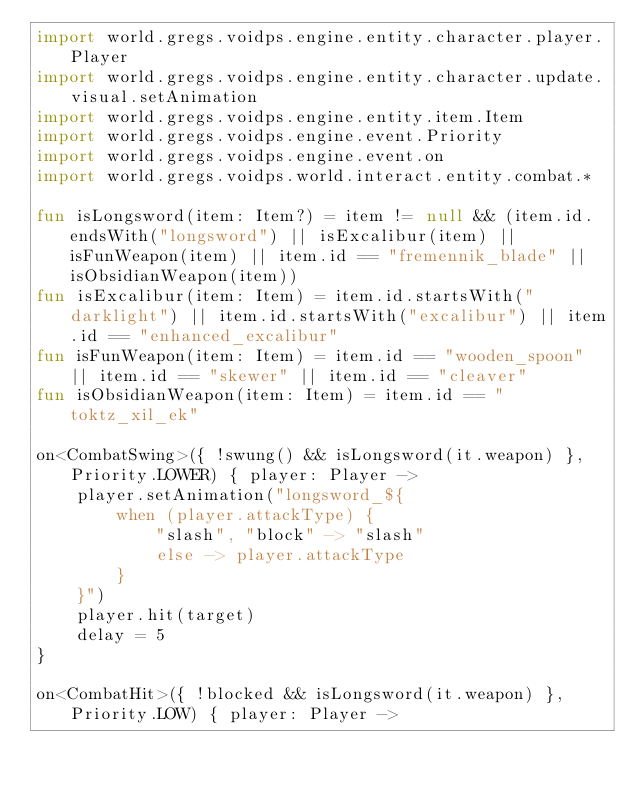Convert code to text. <code><loc_0><loc_0><loc_500><loc_500><_Kotlin_>import world.gregs.voidps.engine.entity.character.player.Player
import world.gregs.voidps.engine.entity.character.update.visual.setAnimation
import world.gregs.voidps.engine.entity.item.Item
import world.gregs.voidps.engine.event.Priority
import world.gregs.voidps.engine.event.on
import world.gregs.voidps.world.interact.entity.combat.*

fun isLongsword(item: Item?) = item != null && (item.id.endsWith("longsword") || isExcalibur(item) || isFunWeapon(item) || item.id == "fremennik_blade" || isObsidianWeapon(item))
fun isExcalibur(item: Item) = item.id.startsWith("darklight") || item.id.startsWith("excalibur") || item.id == "enhanced_excalibur"
fun isFunWeapon(item: Item) = item.id == "wooden_spoon" || item.id == "skewer" || item.id == "cleaver"
fun isObsidianWeapon(item: Item) = item.id == "toktz_xil_ek"

on<CombatSwing>({ !swung() && isLongsword(it.weapon) }, Priority.LOWER) { player: Player ->
    player.setAnimation("longsword_${
        when (player.attackType) {
            "slash", "block" -> "slash"
            else -> player.attackType
        }
    }")
    player.hit(target)
    delay = 5
}

on<CombatHit>({ !blocked && isLongsword(it.weapon) }, Priority.LOW) { player: Player -></code> 